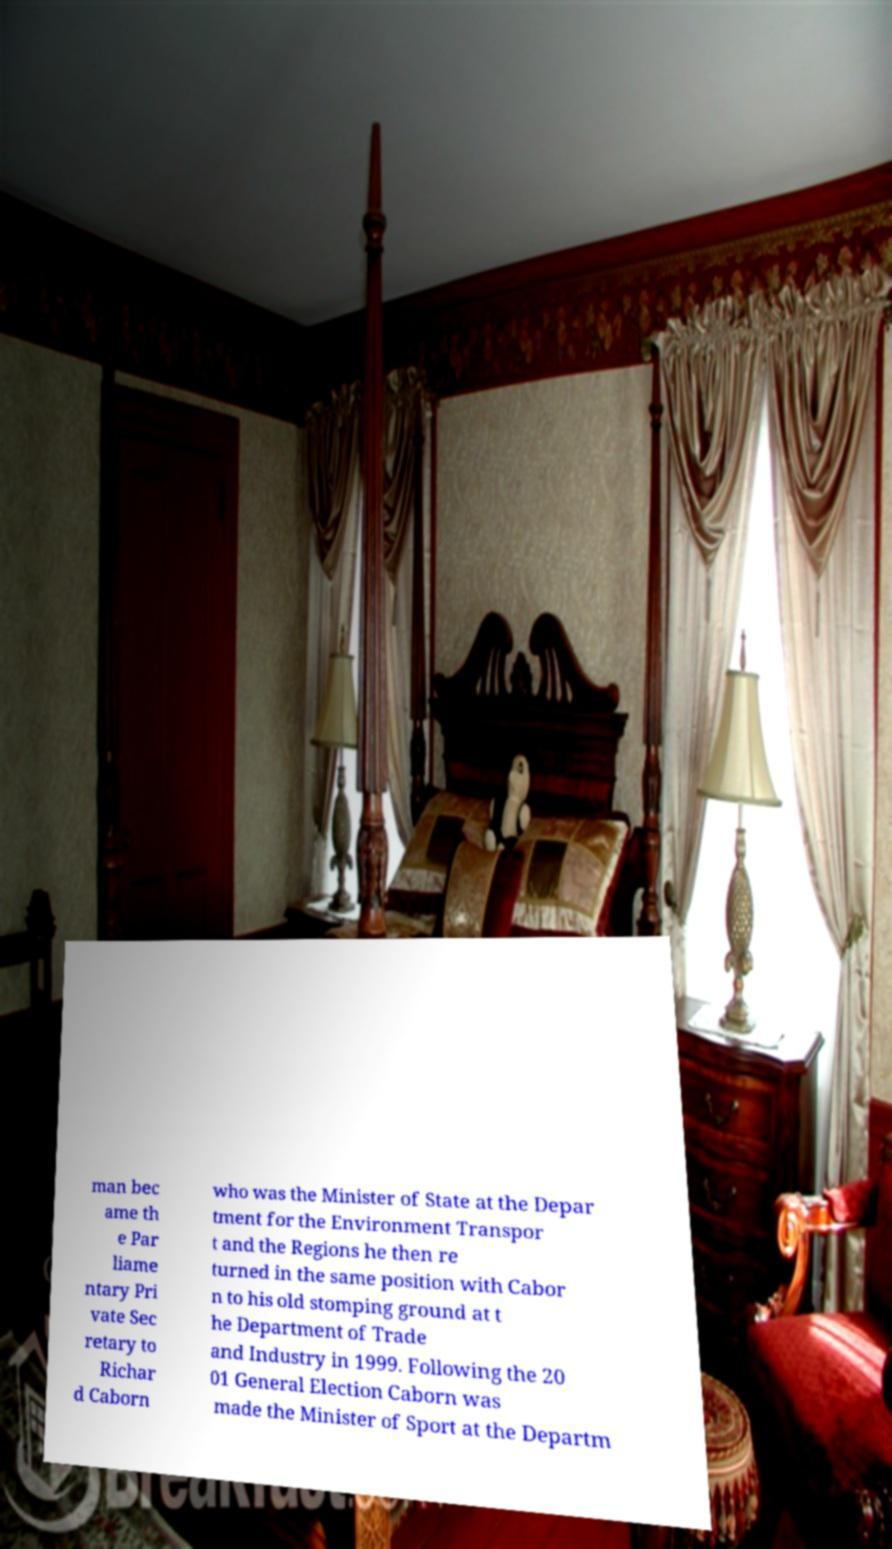For documentation purposes, I need the text within this image transcribed. Could you provide that? man bec ame th e Par liame ntary Pri vate Sec retary to Richar d Caborn who was the Minister of State at the Depar tment for the Environment Transpor t and the Regions he then re turned in the same position with Cabor n to his old stomping ground at t he Department of Trade and Industry in 1999. Following the 20 01 General Election Caborn was made the Minister of Sport at the Departm 